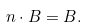<formula> <loc_0><loc_0><loc_500><loc_500>n \cdot B = B .</formula> 